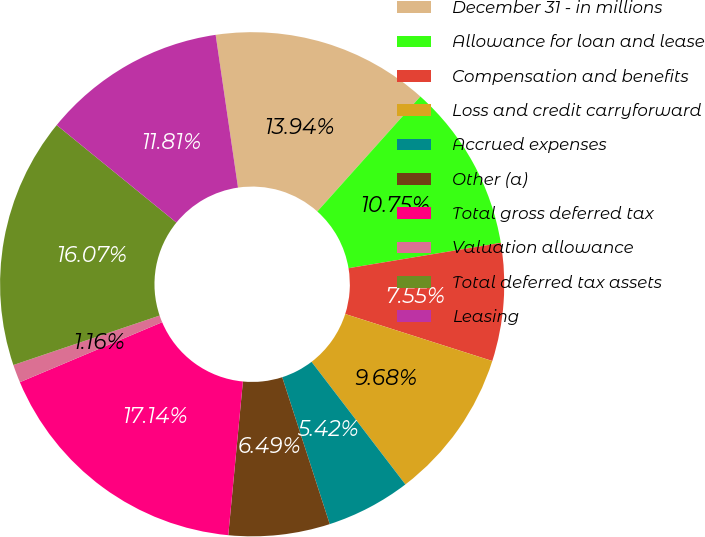<chart> <loc_0><loc_0><loc_500><loc_500><pie_chart><fcel>December 31 - in millions<fcel>Allowance for loan and lease<fcel>Compensation and benefits<fcel>Loss and credit carryforward<fcel>Accrued expenses<fcel>Other (a)<fcel>Total gross deferred tax<fcel>Valuation allowance<fcel>Total deferred tax assets<fcel>Leasing<nl><fcel>13.94%<fcel>10.75%<fcel>7.55%<fcel>9.68%<fcel>5.42%<fcel>6.49%<fcel>17.14%<fcel>1.16%<fcel>16.07%<fcel>11.81%<nl></chart> 